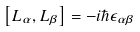Convert formula to latex. <formula><loc_0><loc_0><loc_500><loc_500>\left [ L _ { \alpha } , L _ { \beta } \right ] = - i \hbar { \epsilon } _ { \alpha \beta }</formula> 